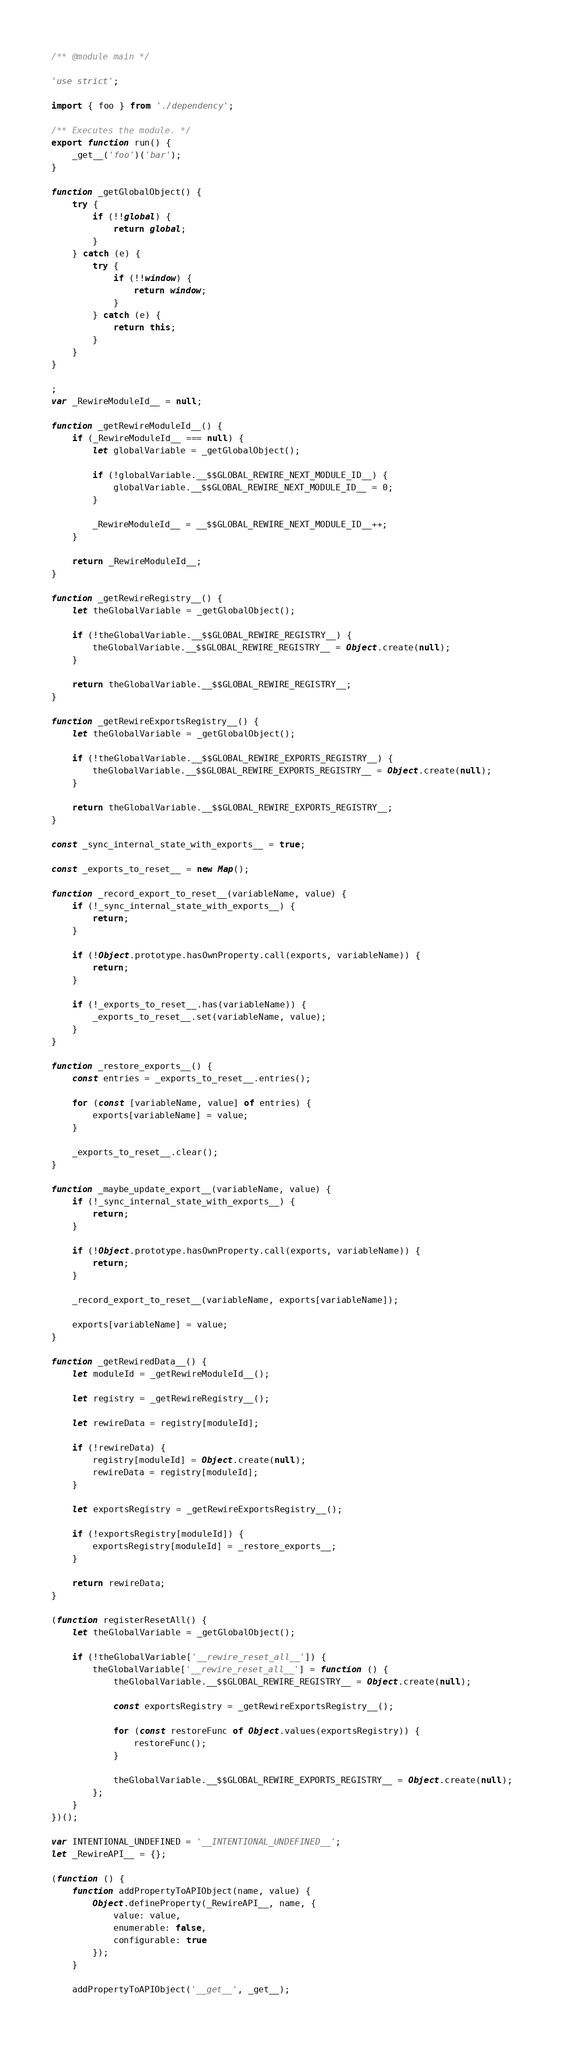Convert code to text. <code><loc_0><loc_0><loc_500><loc_500><_JavaScript_>/** @module main */

'use strict';

import { foo } from './dependency';

/** Executes the module. */
export function run() {
	_get__('foo')('bar');
}

function _getGlobalObject() {
	try {
		if (!!global) {
			return global;
		}
	} catch (e) {
		try {
			if (!!window) {
				return window;
			}
		} catch (e) {
			return this;
		}
	}
}

;
var _RewireModuleId__ = null;

function _getRewireModuleId__() {
	if (_RewireModuleId__ === null) {
		let globalVariable = _getGlobalObject();

		if (!globalVariable.__$$GLOBAL_REWIRE_NEXT_MODULE_ID__) {
			globalVariable.__$$GLOBAL_REWIRE_NEXT_MODULE_ID__ = 0;
		}

		_RewireModuleId__ = __$$GLOBAL_REWIRE_NEXT_MODULE_ID__++;
	}

	return _RewireModuleId__;
}

function _getRewireRegistry__() {
	let theGlobalVariable = _getGlobalObject();

	if (!theGlobalVariable.__$$GLOBAL_REWIRE_REGISTRY__) {
		theGlobalVariable.__$$GLOBAL_REWIRE_REGISTRY__ = Object.create(null);
	}

	return theGlobalVariable.__$$GLOBAL_REWIRE_REGISTRY__;
}

function _getRewireExportsRegistry__() {
	let theGlobalVariable = _getGlobalObject();

	if (!theGlobalVariable.__$$GLOBAL_REWIRE_EXPORTS_REGISTRY__) {
		theGlobalVariable.__$$GLOBAL_REWIRE_EXPORTS_REGISTRY__ = Object.create(null);
	}

	return theGlobalVariable.__$$GLOBAL_REWIRE_EXPORTS_REGISTRY__;
}

const _sync_internal_state_with_exports__ = true;

const _exports_to_reset__ = new Map();

function _record_export_to_reset__(variableName, value) {
	if (!_sync_internal_state_with_exports__) {
		return;
	}

	if (!Object.prototype.hasOwnProperty.call(exports, variableName)) {
		return;
	}

	if (!_exports_to_reset__.has(variableName)) {
		_exports_to_reset__.set(variableName, value);
	}
}

function _restore_exports__() {
	const entries = _exports_to_reset__.entries();

	for (const [variableName, value] of entries) {
		exports[variableName] = value;
	}

	_exports_to_reset__.clear();
}

function _maybe_update_export__(variableName, value) {
	if (!_sync_internal_state_with_exports__) {
		return;
	}

	if (!Object.prototype.hasOwnProperty.call(exports, variableName)) {
		return;
	}

	_record_export_to_reset__(variableName, exports[variableName]);

	exports[variableName] = value;
}

function _getRewiredData__() {
	let moduleId = _getRewireModuleId__();

	let registry = _getRewireRegistry__();

	let rewireData = registry[moduleId];

	if (!rewireData) {
		registry[moduleId] = Object.create(null);
		rewireData = registry[moduleId];
	}

	let exportsRegistry = _getRewireExportsRegistry__();

	if (!exportsRegistry[moduleId]) {
		exportsRegistry[moduleId] = _restore_exports__;
	}

	return rewireData;
}

(function registerResetAll() {
	let theGlobalVariable = _getGlobalObject();

	if (!theGlobalVariable['__rewire_reset_all__']) {
		theGlobalVariable['__rewire_reset_all__'] = function () {
			theGlobalVariable.__$$GLOBAL_REWIRE_REGISTRY__ = Object.create(null);

			const exportsRegistry = _getRewireExportsRegistry__();

			for (const restoreFunc of Object.values(exportsRegistry)) {
				restoreFunc();
			}

			theGlobalVariable.__$$GLOBAL_REWIRE_EXPORTS_REGISTRY__ = Object.create(null);
		};
	}
})();

var INTENTIONAL_UNDEFINED = '__INTENTIONAL_UNDEFINED__';
let _RewireAPI__ = {};

(function () {
	function addPropertyToAPIObject(name, value) {
		Object.defineProperty(_RewireAPI__, name, {
			value: value,
			enumerable: false,
			configurable: true
		});
	}

	addPropertyToAPIObject('__get__', _get__);</code> 